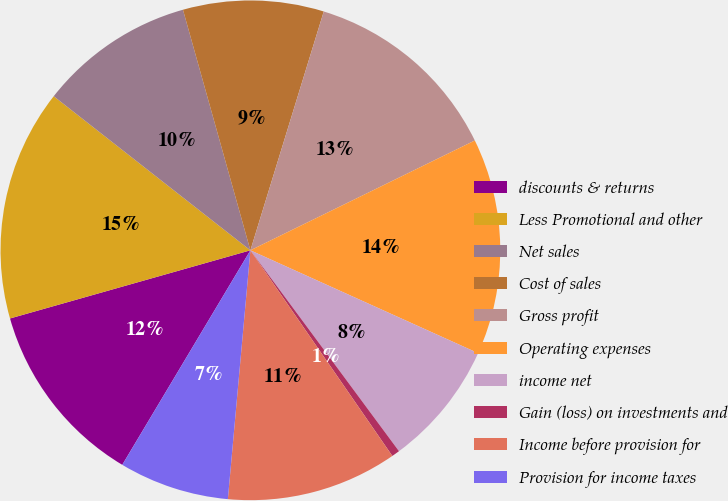Convert chart. <chart><loc_0><loc_0><loc_500><loc_500><pie_chart><fcel>discounts & returns<fcel>Less Promotional and other<fcel>Net sales<fcel>Cost of sales<fcel>Gross profit<fcel>Operating expenses<fcel>income net<fcel>Gain (loss) on investments and<fcel>Income before provision for<fcel>Provision for income taxes<nl><fcel>12.03%<fcel>14.97%<fcel>10.07%<fcel>9.09%<fcel>13.01%<fcel>13.99%<fcel>8.11%<fcel>0.52%<fcel>11.05%<fcel>7.13%<nl></chart> 